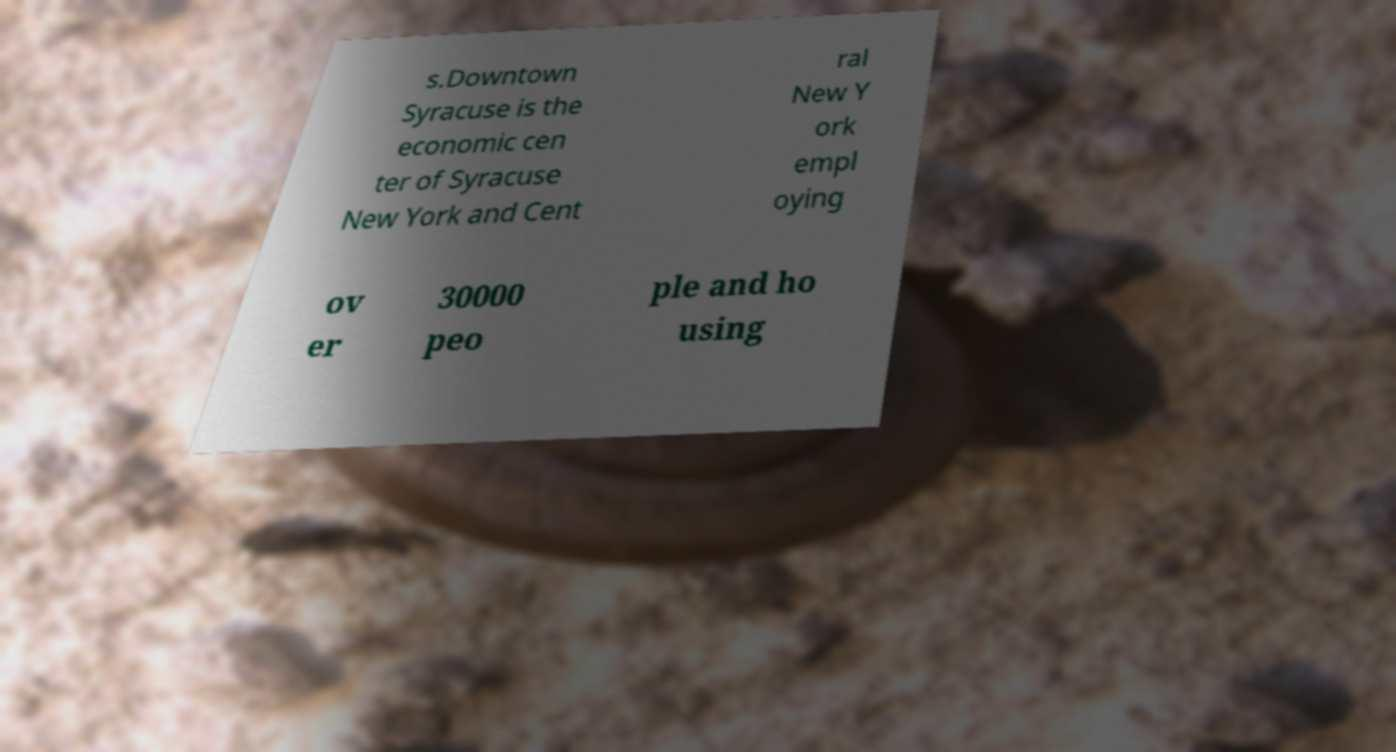What messages or text are displayed in this image? I need them in a readable, typed format. s.Downtown Syracuse is the economic cen ter of Syracuse New York and Cent ral New Y ork empl oying ov er 30000 peo ple and ho using 